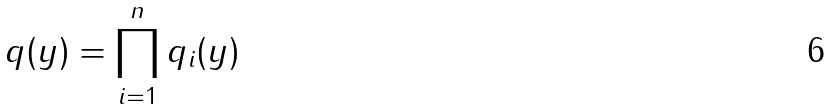<formula> <loc_0><loc_0><loc_500><loc_500>q ( y ) = \prod _ { i = 1 } ^ { n } q _ { i } ( y )</formula> 